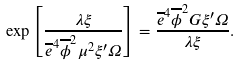Convert formula to latex. <formula><loc_0><loc_0><loc_500><loc_500>\exp \left [ \frac { \lambda \xi } { \overline { e } ^ { 4 } \overline { \phi } ^ { 2 } \mu ^ { 2 } \xi ^ { \prime } \Omega } \right ] = \frac { \overline { e } ^ { 4 } \overline { \phi } ^ { 2 } G \xi ^ { \prime } \Omega } { \lambda \xi } .</formula> 